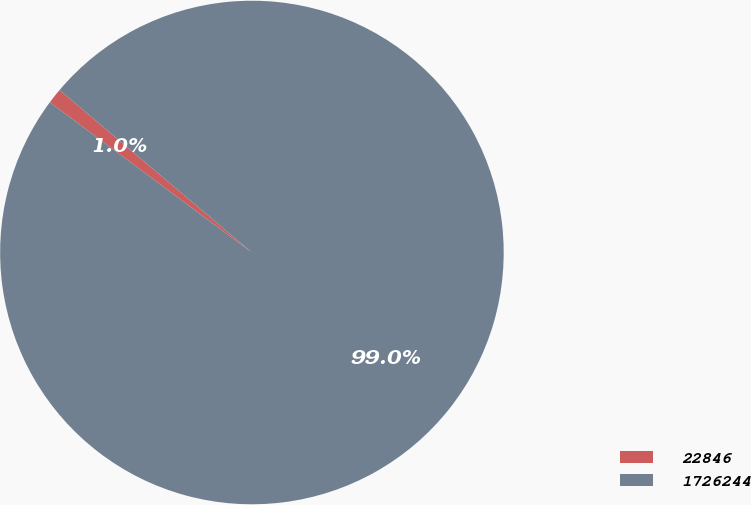<chart> <loc_0><loc_0><loc_500><loc_500><pie_chart><fcel>22846<fcel>1726244<nl><fcel>0.99%<fcel>99.01%<nl></chart> 